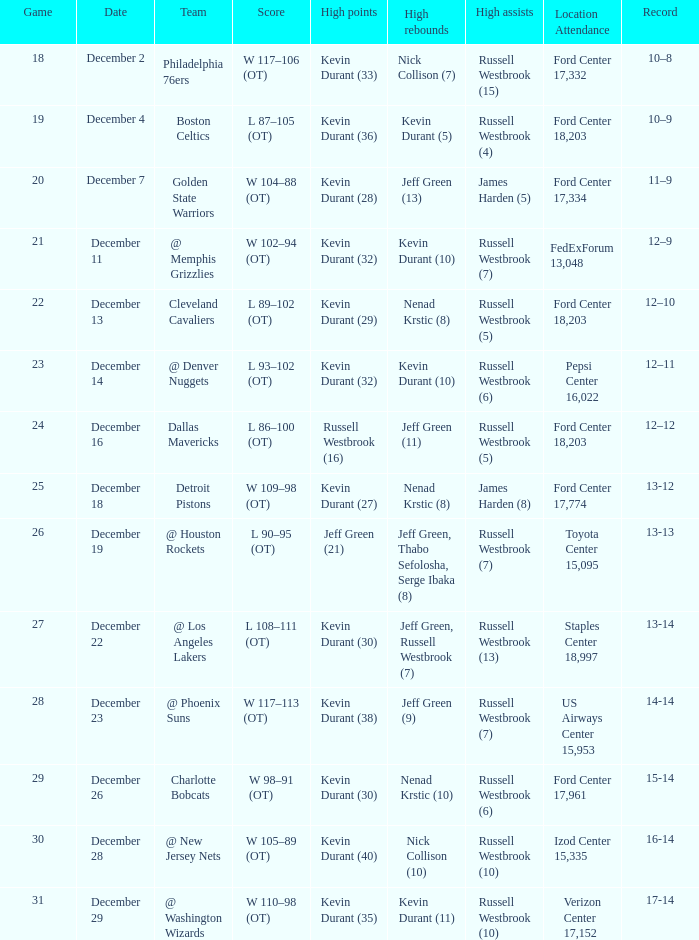Who has high points when toyota center 15,095 is location attendance? Jeff Green (21). 